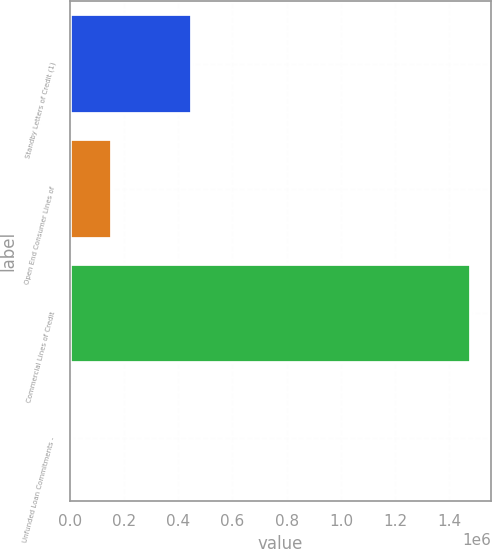Convert chart. <chart><loc_0><loc_0><loc_500><loc_500><bar_chart><fcel>Standby Letters of Credit (1)<fcel>Open End Consumer Lines of<fcel>Commercial Lines of Credit<fcel>Unfunded Loan Commitments -<nl><fcel>449065<fcel>154724<fcel>1.47926e+06<fcel>7553<nl></chart> 